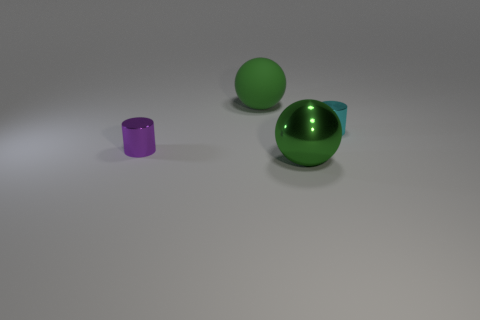Add 1 small purple matte cylinders. How many objects exist? 5 Add 4 cyan things. How many cyan things exist? 5 Subtract 0 purple cubes. How many objects are left? 4 Subtract all green metallic things. Subtract all shiny things. How many objects are left? 0 Add 4 green metal things. How many green metal things are left? 5 